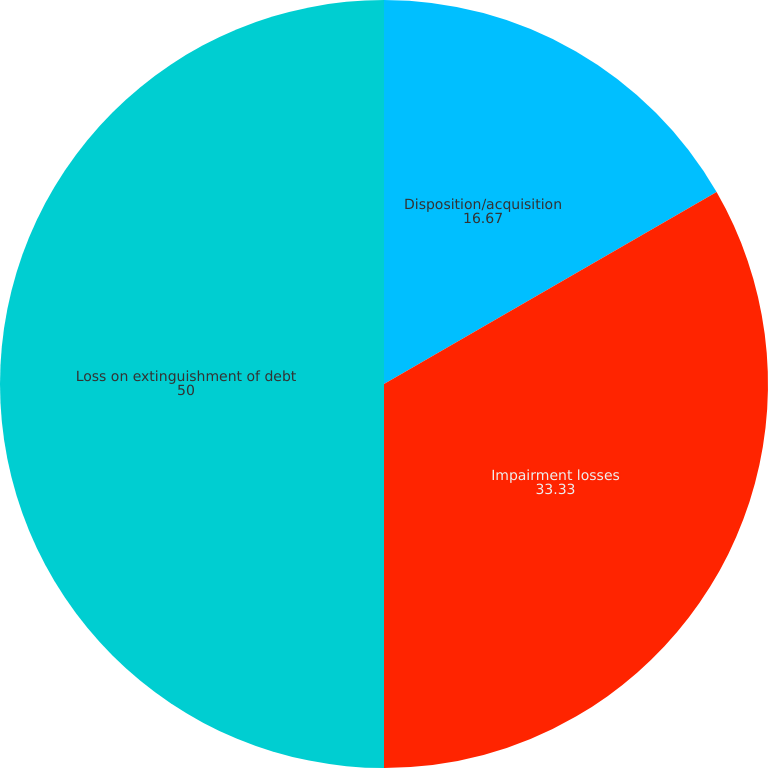Convert chart to OTSL. <chart><loc_0><loc_0><loc_500><loc_500><pie_chart><fcel>Disposition/acquisition<fcel>Impairment losses<fcel>Loss on extinguishment of debt<nl><fcel>16.67%<fcel>33.33%<fcel>50.0%<nl></chart> 